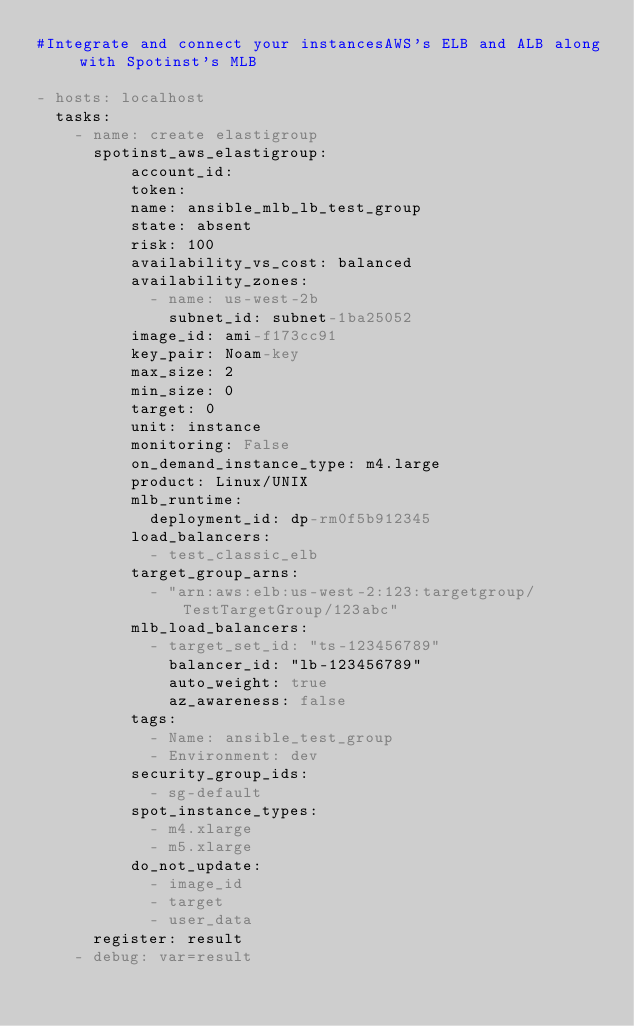<code> <loc_0><loc_0><loc_500><loc_500><_YAML_>#Integrate and connect your instancesAWS's ELB and ALB along with Spotinst's MLB

- hosts: localhost
  tasks:
    - name: create elastigroup
      spotinst_aws_elastigroup:
          account_id: 
          token: 
          name: ansible_mlb_lb_test_group
          state: absent
          risk: 100
          availability_vs_cost: balanced
          availability_zones:
            - name: us-west-2b
              subnet_id: subnet-1ba25052
          image_id: ami-f173cc91
          key_pair: Noam-key
          max_size: 2
          min_size: 0
          target: 0
          unit: instance
          monitoring: False
          on_demand_instance_type: m4.large
          product: Linux/UNIX
          mlb_runtime:
            deployment_id: dp-rm0f5b912345
          load_balancers:
            - test_classic_elb
          target_group_arns:
            - "arn:aws:elb:us-west-2:123:targetgroup/TestTargetGroup/123abc"
          mlb_load_balancers:
            - target_set_id: "ts-123456789"
              balancer_id: "lb-123456789"
              auto_weight: true
              az_awareness: false
          tags:
            - Name: ansible_test_group
            - Environment: dev
          security_group_ids:
            - sg-default
          spot_instance_types:
            - m4.xlarge
            - m5.xlarge
          do_not_update:
            - image_id
            - target
            - user_data
      register: result
    - debug: var=result</code> 